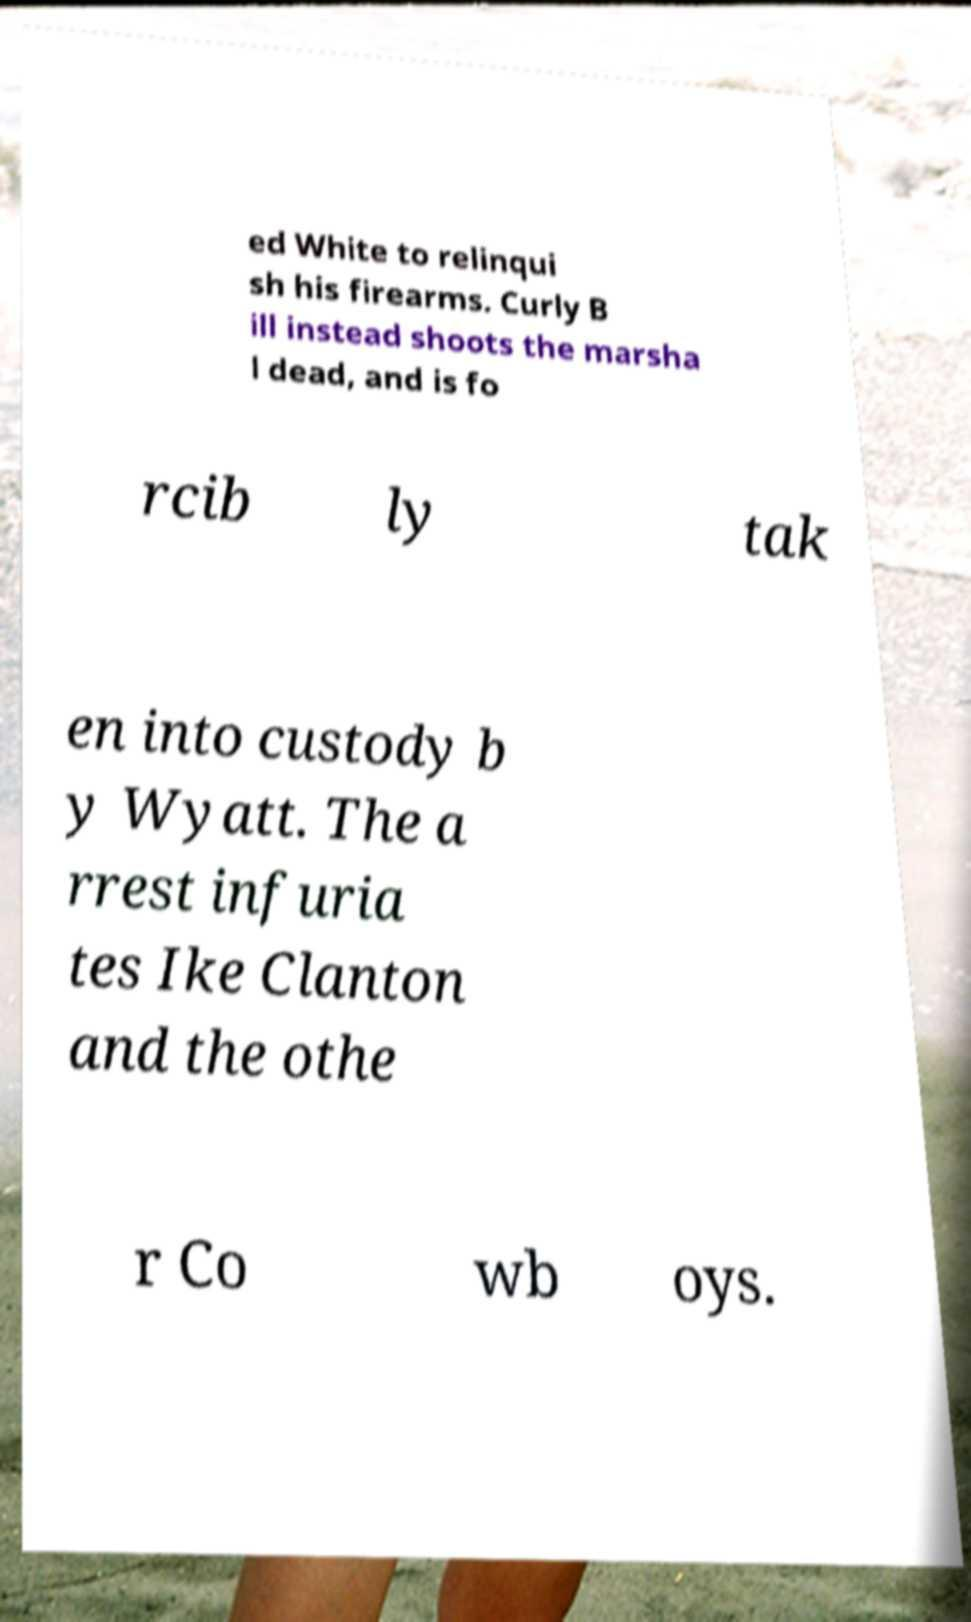Can you accurately transcribe the text from the provided image for me? ed White to relinqui sh his firearms. Curly B ill instead shoots the marsha l dead, and is fo rcib ly tak en into custody b y Wyatt. The a rrest infuria tes Ike Clanton and the othe r Co wb oys. 